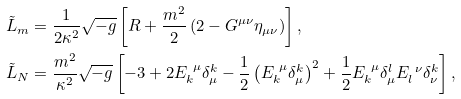Convert formula to latex. <formula><loc_0><loc_0><loc_500><loc_500>\tilde { L } _ { m } & = \frac { 1 } { 2 \kappa ^ { 2 } } \sqrt { - g } \left [ R + \frac { m ^ { 2 } } { 2 } \left ( 2 - G ^ { \mu \nu } \eta _ { \mu \nu } \right ) \right ] , \\ \tilde { L } _ { N } & = \frac { m ^ { 2 } } { \kappa ^ { 2 } } \sqrt { - g } \left [ - 3 + 2 E _ { k } ^ { \ \mu } \delta _ { \mu } ^ { k } - \frac { 1 } { 2 } \left ( E _ { k } ^ { \ \mu } \delta _ { \mu } ^ { k } \right ) ^ { 2 } + \frac { 1 } { 2 } E _ { k } ^ { \ \mu } \delta _ { \mu } ^ { l } E _ { l } ^ { \ \nu } \delta _ { \nu } ^ { k } \right ] ,</formula> 